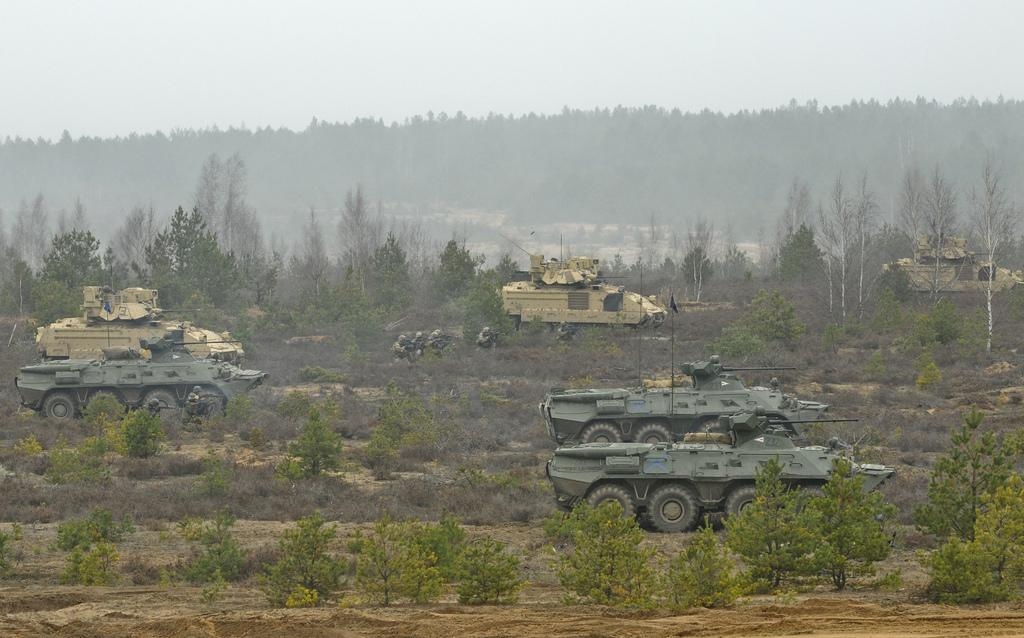What type of vehicles are present in the image? There are military vehicles in the image. What other elements can be seen in the image besides the vehicles? There are plants and trees in the image. What part of the natural environment is visible in the image? The sky is visible in the image. What type of alley can be seen in the image? There is no alley present in the image. 